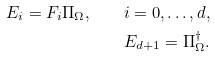<formula> <loc_0><loc_0><loc_500><loc_500>E _ { i } = F _ { i } \Pi _ { \Omega } , \quad i = 0 , \dots , d , \\ E _ { d + 1 } = \Pi _ { \Omega } ^ { \dag } .</formula> 